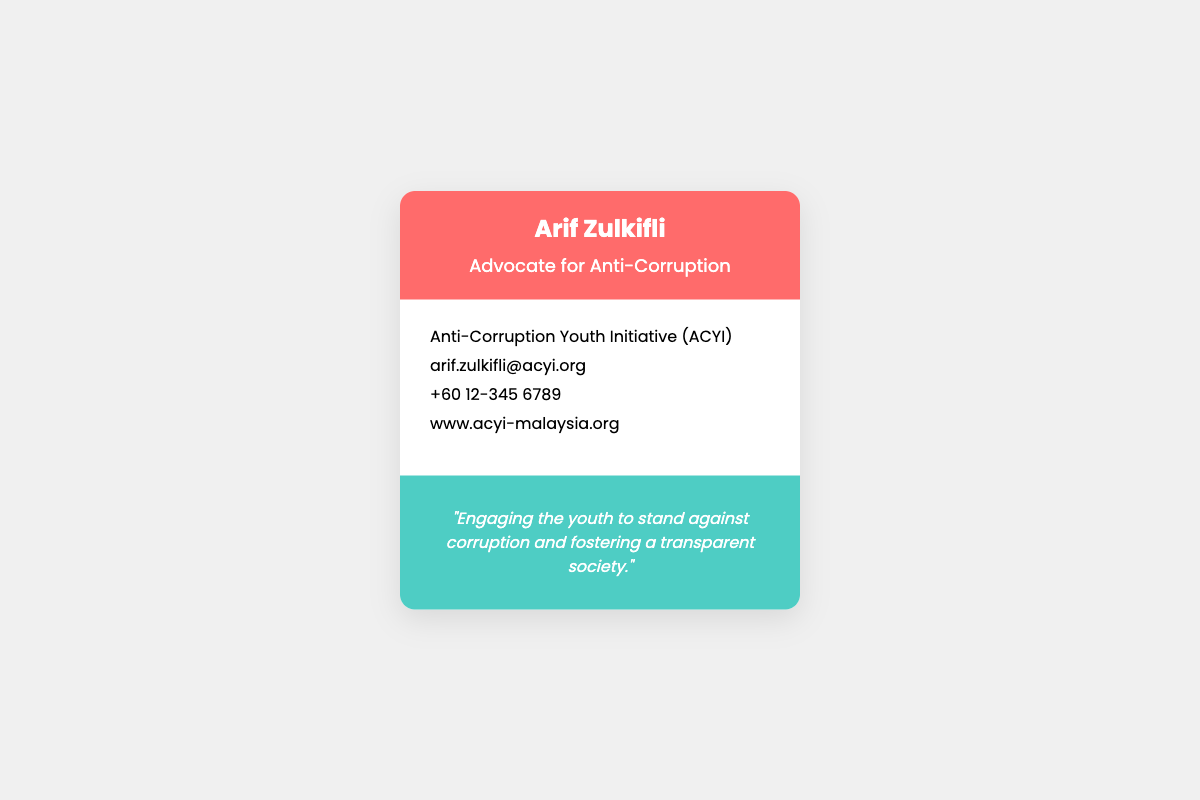What is the name of the advocate? The document features the name of the advocate prominently in the header, which is Arif Zulkifli.
Answer: Arif Zulkifli What is the title of the advocate? The title of the advocate is provided in the header under the name, indicating their role in fighting corruption.
Answer: Advocate for Anti-Corruption What organization is associated with the advocate? The document mentions the organization name right beneath the advocate's contact information, which focuses on anti-corruption.
Answer: Anti-Corruption Youth Initiative (ACYI) What is the email address listed? The email address is clearly mentioned in the info section of the card, representative of the advocate's professional communication.
Answer: arif.zulkifli@acyi.org What is the contact phone number? The phone number is outlined in the info section, allowing for direct communication with the advocate.
Answer: +60 12-345 6789 What is the mission statement about? The mission statement at the bottom of the card articulates the advocate's commitment to engaging youth against corruption.
Answer: Engaging the youth to stand against corruption and fostering a transparent society How many social media platforms are linked? The document contains icons for three social media platforms, suggesting the advocate's engagement in these forums.
Answer: Three What color is the header background? The header background features a specific color that stands out, which is noticeable in the document.
Answer: #FF6B6B What is the website of the organization? The website is provided in the content section for further information about the organization.
Answer: www.acyi-malaysia.org 